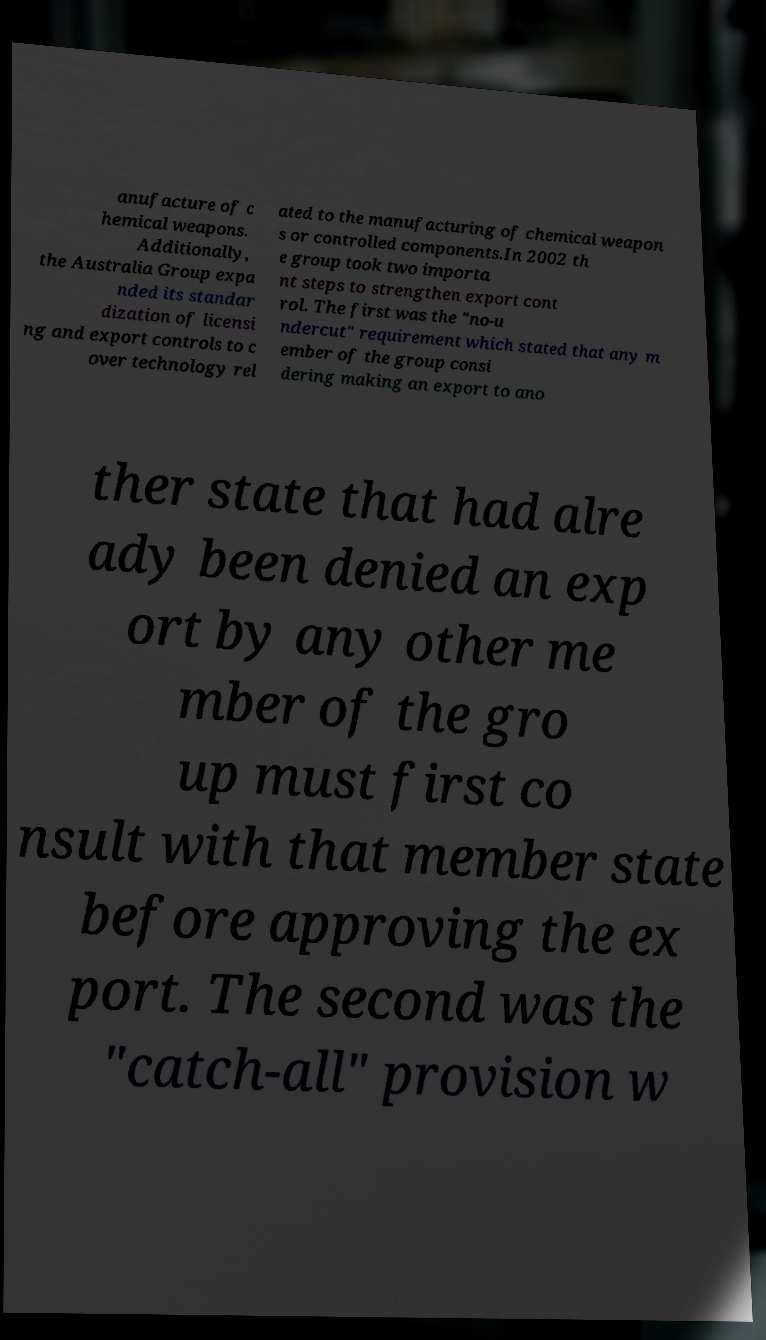Please read and relay the text visible in this image. What does it say? anufacture of c hemical weapons. Additionally, the Australia Group expa nded its standar dization of licensi ng and export controls to c over technology rel ated to the manufacturing of chemical weapon s or controlled components.In 2002 th e group took two importa nt steps to strengthen export cont rol. The first was the "no-u ndercut" requirement which stated that any m ember of the group consi dering making an export to ano ther state that had alre ady been denied an exp ort by any other me mber of the gro up must first co nsult with that member state before approving the ex port. The second was the "catch-all" provision w 